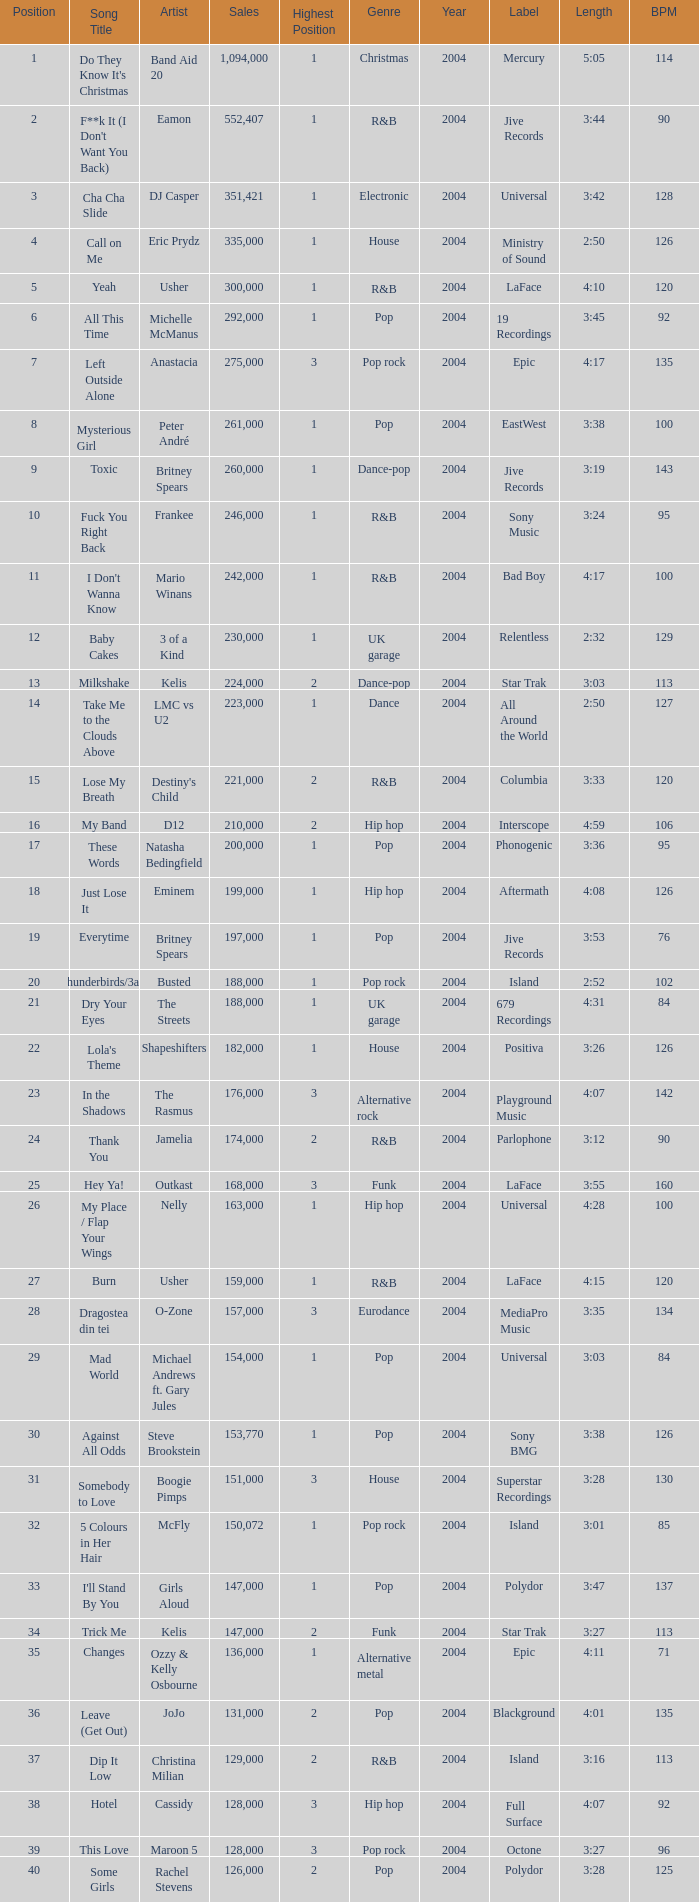What is the most sales by a song with a position higher than 3? None. 